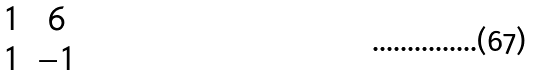<formula> <loc_0><loc_0><loc_500><loc_500>\begin{matrix} 1 & 6 \\ 1 & - 1 \end{matrix}</formula> 